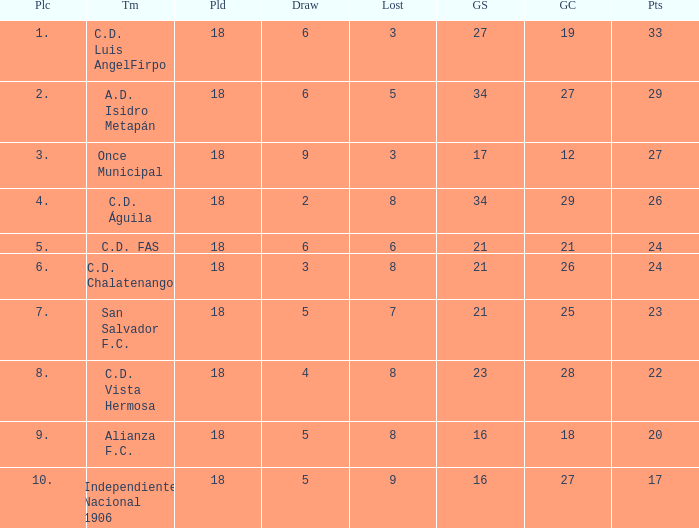For Once Municipal, what were the goals scored that had less than 27 points and greater than place 1? None. 